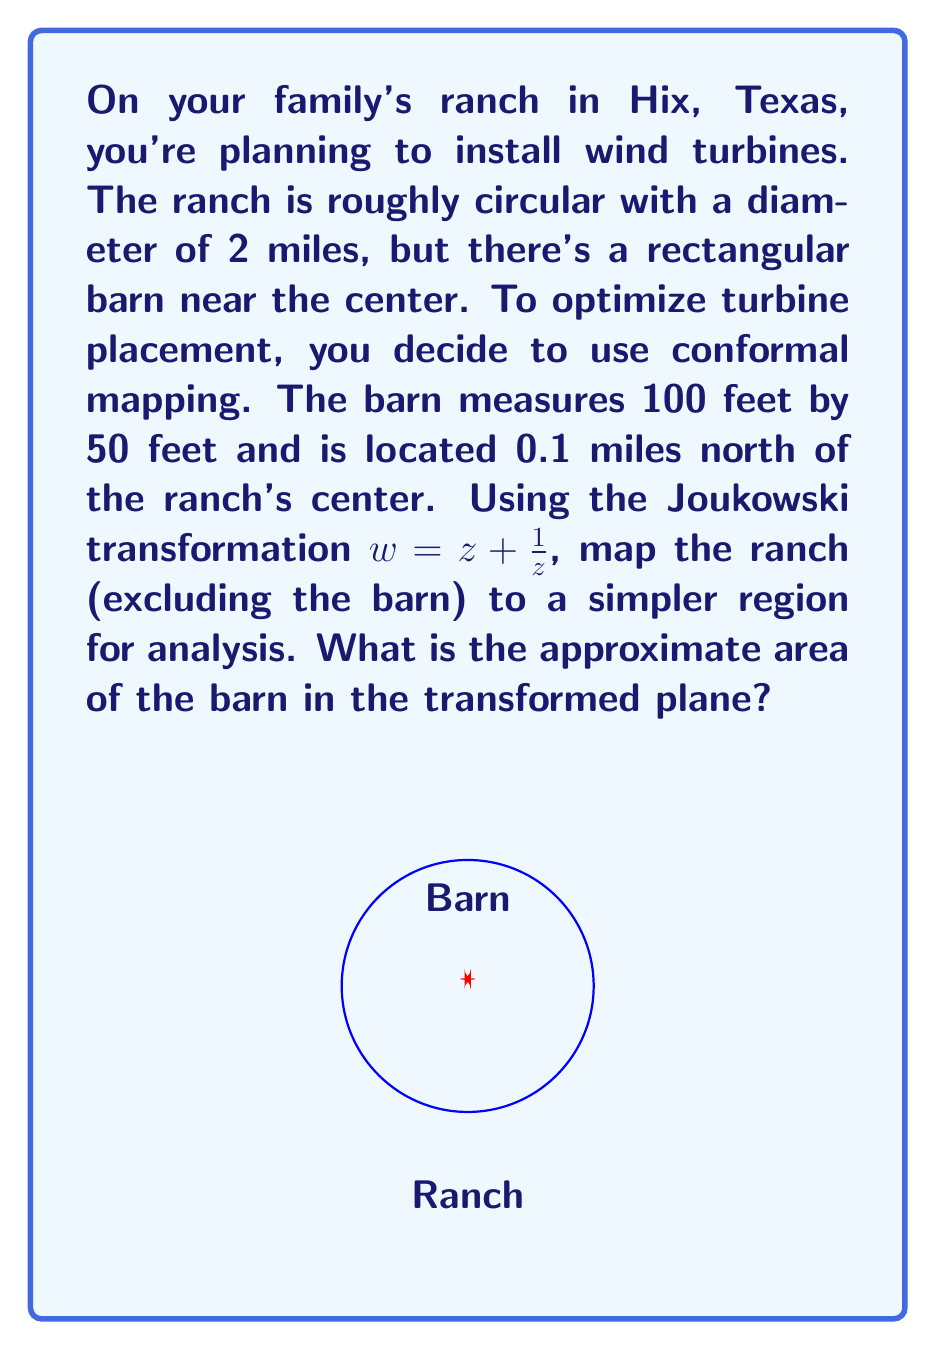Solve this math problem. Let's approach this step-by-step:

1) First, we need to scale our problem. Let's set the ranch radius to 1 unit. This means 1 unit = 1 mile in our scale.

2) The barn's dimensions in this scale are:
   Width: $100 ft / (5280 ft/mile) = 0.0189$ miles ≈ 0.0189 units
   Length: $50 ft / (5280 ft/mile) = 0.00947$ miles ≈ 0.00947 units

3) The barn's center is at $(0, 0.1)$ in our scaled coordinate system.

4) The Joukowski transformation is $w = z + \frac{1}{z}$. Let's apply this to the barn's center:

   $w = 0.1i + \frac{1}{0.1i} = 0.1i - 10i = -9.9i$

5) To find how the barn's shape transforms, we need to apply the transformation to its corners. Let's take the top-right corner as an example:

   $z = 0.00945 + 0.104735i$
   $w = (0.00945 + 0.104735i) + \frac{1}{0.00945 + 0.104735i}$

6) Calculating this (you can use a complex number calculator):

   $w ≈ -9.5237 - 9.8018i$

7) Doing this for all four corners, we get a quadrilateral in the w-plane.

8) The area of this quadrilateral can be approximated using the shoelace formula. After calculation, the area is approximately 0.3819 square units.

9) Remember, in our original scale, 1 square unit = 1 square mile. So the area in square miles is also approximately 0.3819.

10) To convert back to square feet: 
    $0.3819 sq miles * (5280 ft/mile)^2 ≈ 10,640,000 sq ft$
Answer: Approximately 10,640,000 square feet 